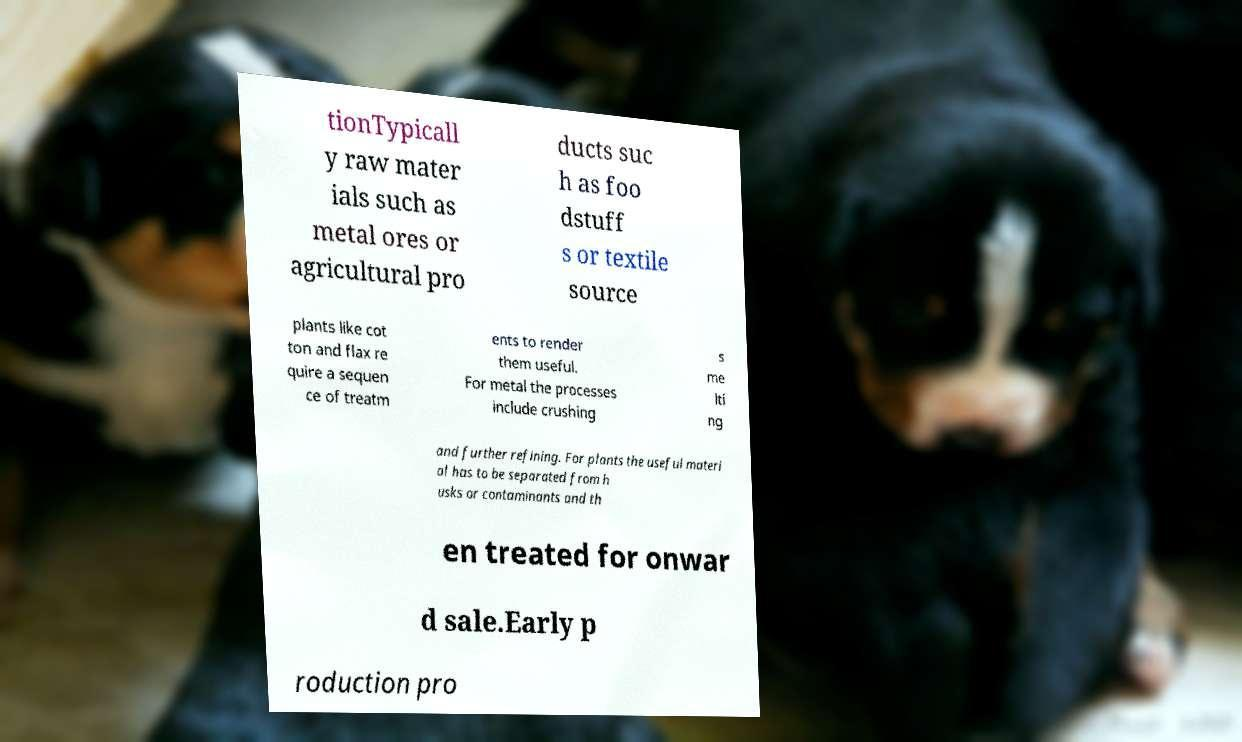Could you assist in decoding the text presented in this image and type it out clearly? tionTypicall y raw mater ials such as metal ores or agricultural pro ducts suc h as foo dstuff s or textile source plants like cot ton and flax re quire a sequen ce of treatm ents to render them useful. For metal the processes include crushing s me lti ng and further refining. For plants the useful materi al has to be separated from h usks or contaminants and th en treated for onwar d sale.Early p roduction pro 